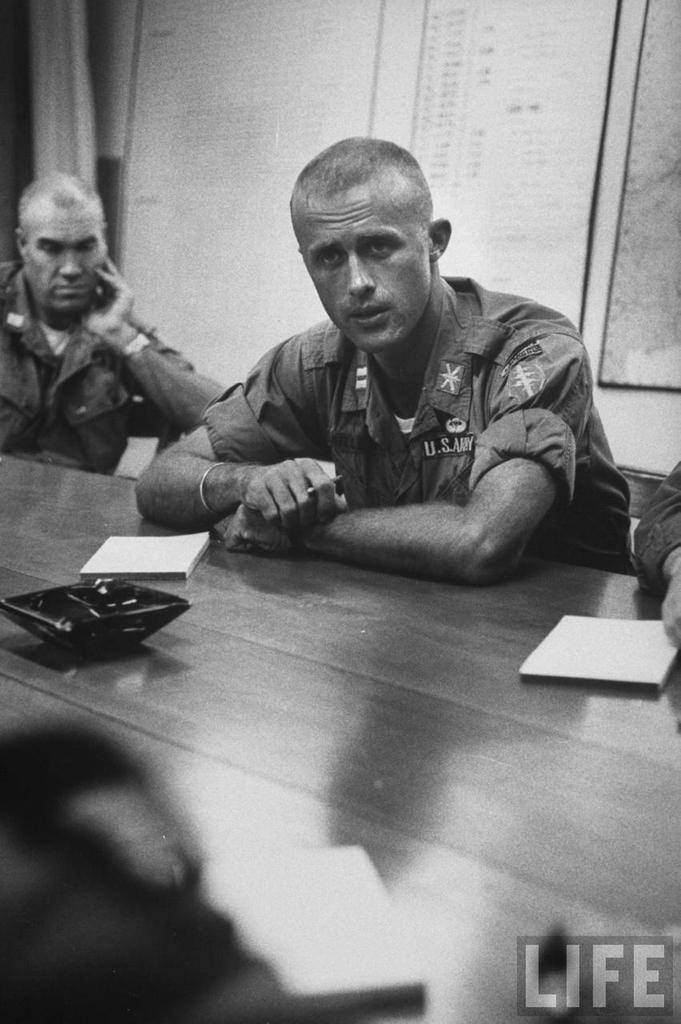What are the people in the image doing? The people in the image are sitting on chairs. Where are the chairs located in relation to the table? The chairs are in front of the table. What items can be seen on the table? There are books and an unspecified object on the table. How would you describe the lighting in the image? The background of the image is dark. What type of clover is growing on the table in the image? There is no clover present in the image; the table has books and an unspecified object on it. 